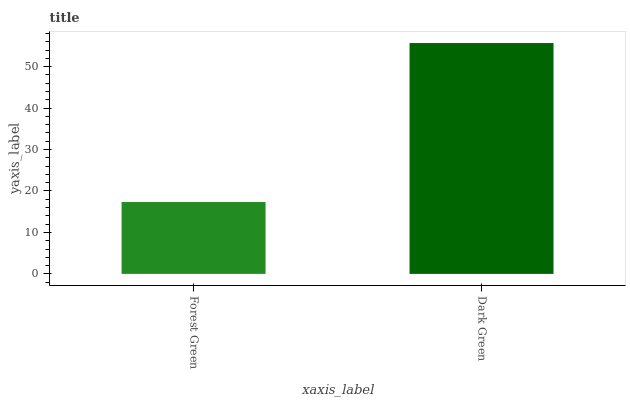Is Dark Green the minimum?
Answer yes or no. No. Is Dark Green greater than Forest Green?
Answer yes or no. Yes. Is Forest Green less than Dark Green?
Answer yes or no. Yes. Is Forest Green greater than Dark Green?
Answer yes or no. No. Is Dark Green less than Forest Green?
Answer yes or no. No. Is Dark Green the high median?
Answer yes or no. Yes. Is Forest Green the low median?
Answer yes or no. Yes. Is Forest Green the high median?
Answer yes or no. No. Is Dark Green the low median?
Answer yes or no. No. 